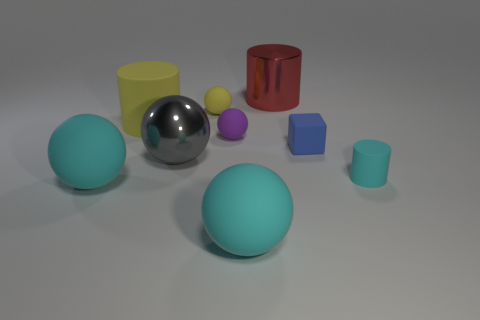Do the big metallic cylinder and the small rubber block have the same color?
Give a very brief answer. No. How many things are big green shiny cylinders or cyan rubber things to the right of the large yellow matte cylinder?
Ensure brevity in your answer.  2. There is a cyan rubber thing on the left side of the big cyan sphere that is right of the yellow sphere; what number of tiny cylinders are behind it?
Provide a succinct answer. 1. There is a thing that is the same color as the large matte cylinder; what material is it?
Give a very brief answer. Rubber. How many small red metal objects are there?
Give a very brief answer. 0. There is a cyan rubber thing to the left of the gray metallic ball; is its size the same as the small yellow matte thing?
Your response must be concise. No. How many matte things are either small cylinders or big gray things?
Your answer should be very brief. 1. What number of tiny yellow rubber spheres are in front of the large metal object left of the large red cylinder?
Offer a terse response. 0. There is a cyan matte object that is in front of the tiny cyan matte cylinder and to the right of the yellow cylinder; what shape is it?
Ensure brevity in your answer.  Sphere. The large cylinder in front of the metallic object that is to the right of the metal object in front of the tiny yellow ball is made of what material?
Provide a short and direct response. Rubber. 